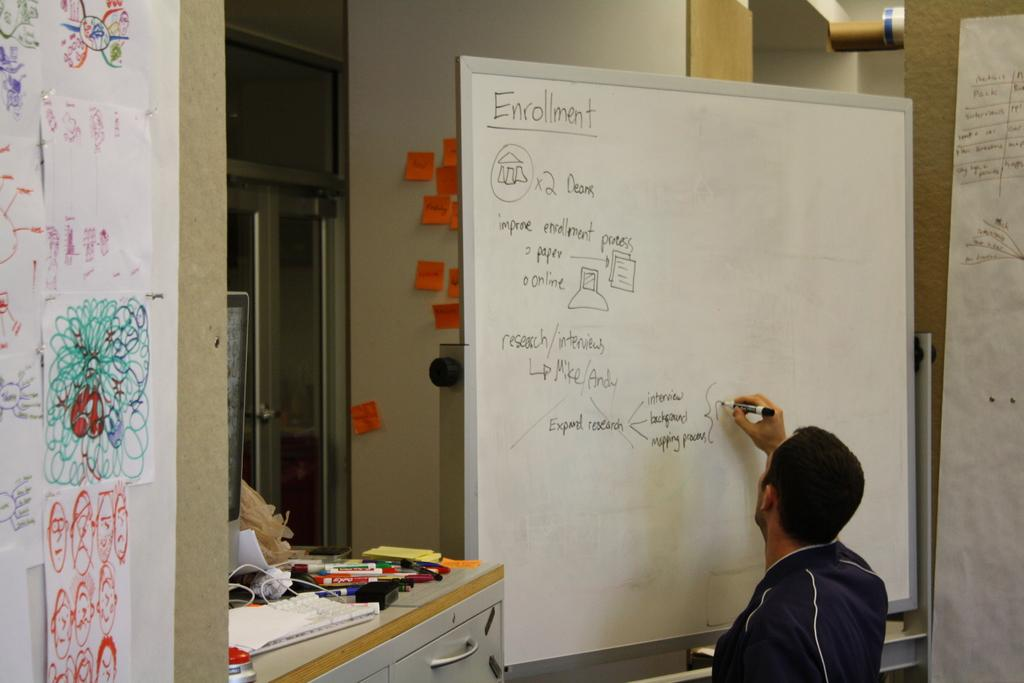Provide a one-sentence caption for the provided image. A man is writing on a whiteboard that says enrollment. 